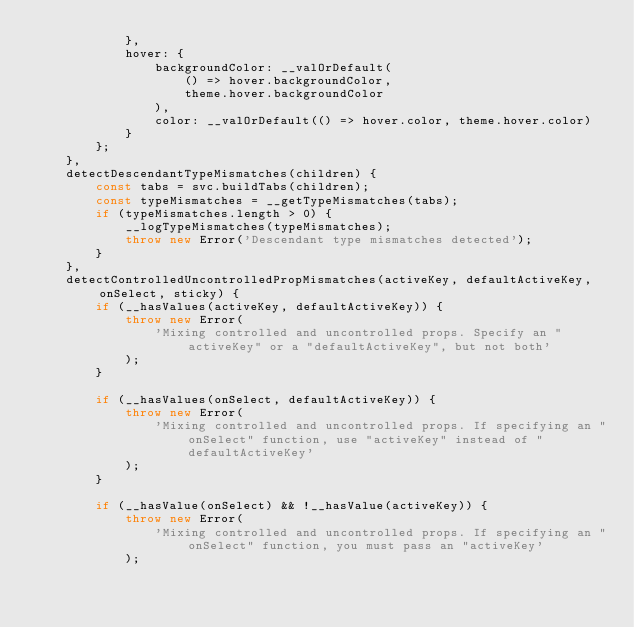Convert code to text. <code><loc_0><loc_0><loc_500><loc_500><_JavaScript_>            },
            hover: {
                backgroundColor: __valOrDefault(
                    () => hover.backgroundColor,
                    theme.hover.backgroundColor
                ),
                color: __valOrDefault(() => hover.color, theme.hover.color)
            }
        };
    },
    detectDescendantTypeMismatches(children) {
        const tabs = svc.buildTabs(children);
        const typeMismatches = __getTypeMismatches(tabs);
        if (typeMismatches.length > 0) {
            __logTypeMismatches(typeMismatches);
            throw new Error('Descendant type mismatches detected');
        }
    },
    detectControlledUncontrolledPropMismatches(activeKey, defaultActiveKey, onSelect, sticky) {
        if (__hasValues(activeKey, defaultActiveKey)) {
            throw new Error(
                'Mixing controlled and uncontrolled props. Specify an "activeKey" or a "defaultActiveKey", but not both'
            );
        }

        if (__hasValues(onSelect, defaultActiveKey)) {
            throw new Error(
                'Mixing controlled and uncontrolled props. If specifying an "onSelect" function, use "activeKey" instead of "defaultActiveKey'
            );
        }

        if (__hasValue(onSelect) && !__hasValue(activeKey)) {
            throw new Error(
                'Mixing controlled and uncontrolled props. If specifying an "onSelect" function, you must pass an "activeKey'
            );</code> 